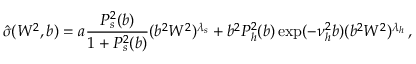<formula> <loc_0><loc_0><loc_500><loc_500>{ \hat { \sigma } } ( W ^ { 2 } , b ) = a \frac { P _ { s } ^ { 2 } ( b ) } { 1 + P _ { s } ^ { 2 } ( b ) } ( b ^ { 2 } W ^ { 2 } ) ^ { \lambda _ { s } } + b ^ { 2 } P _ { h } ^ { 2 } ( b ) \exp ( - \nu _ { h } ^ { 2 } b ) ( b ^ { 2 } W ^ { 2 } ) ^ { \lambda _ { h } } \, ,</formula> 